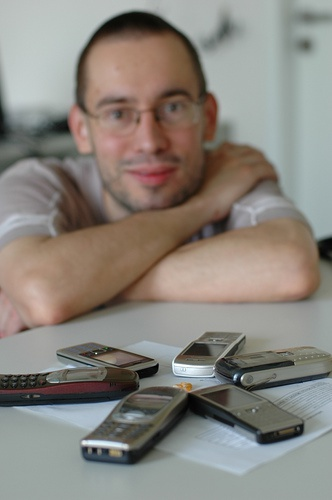Describe the objects in this image and their specific colors. I can see people in darkgray and gray tones, dining table in darkgray, gray, and black tones, cell phone in darkgray, gray, and black tones, cell phone in darkgray, gray, and black tones, and cell phone in darkgray, black, maroon, and gray tones in this image. 